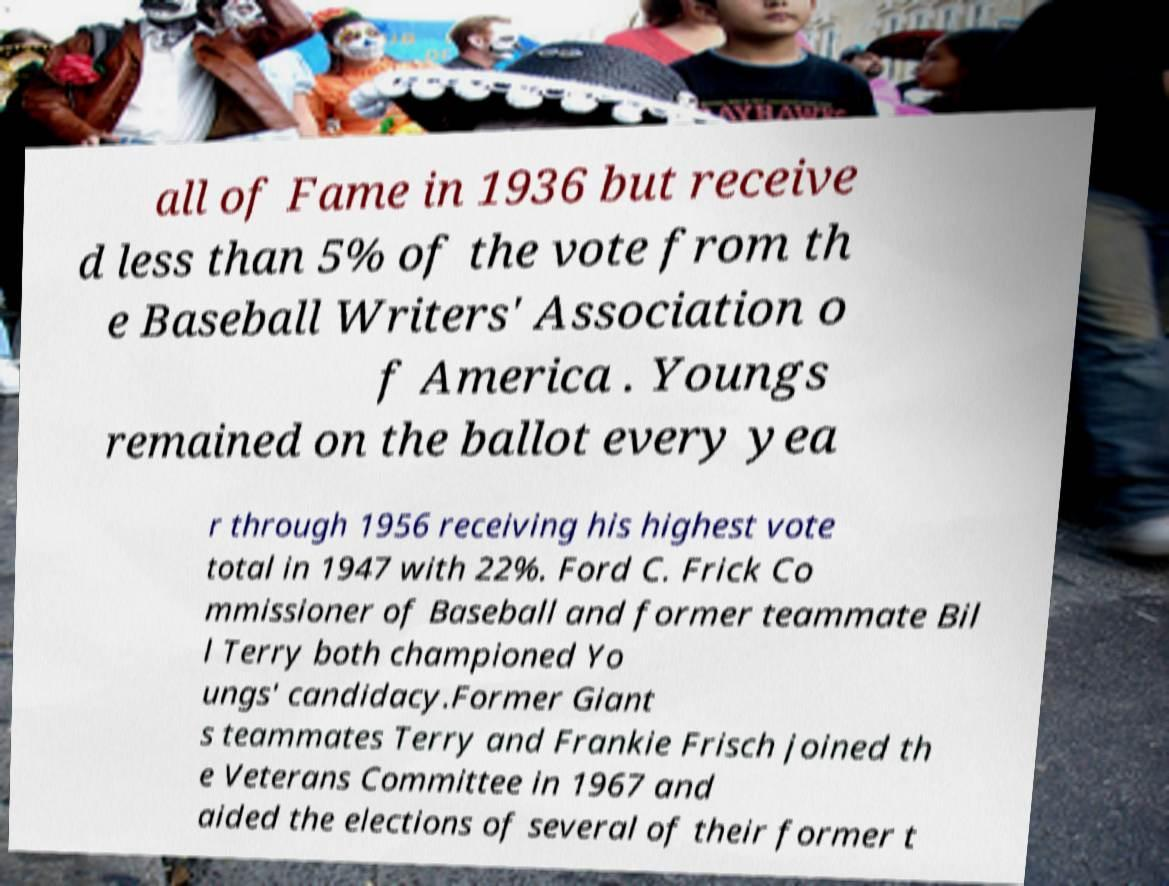I need the written content from this picture converted into text. Can you do that? all of Fame in 1936 but receive d less than 5% of the vote from th e Baseball Writers' Association o f America . Youngs remained on the ballot every yea r through 1956 receiving his highest vote total in 1947 with 22%. Ford C. Frick Co mmissioner of Baseball and former teammate Bil l Terry both championed Yo ungs' candidacy.Former Giant s teammates Terry and Frankie Frisch joined th e Veterans Committee in 1967 and aided the elections of several of their former t 